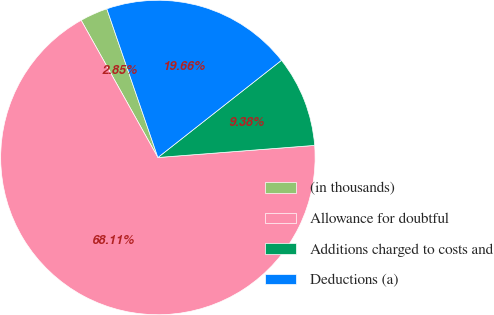Convert chart. <chart><loc_0><loc_0><loc_500><loc_500><pie_chart><fcel>(in thousands)<fcel>Allowance for doubtful<fcel>Additions charged to costs and<fcel>Deductions (a)<nl><fcel>2.85%<fcel>68.11%<fcel>9.38%<fcel>19.66%<nl></chart> 